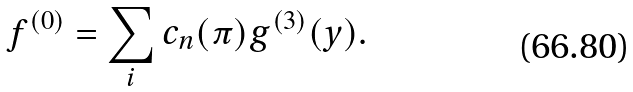Convert formula to latex. <formula><loc_0><loc_0><loc_500><loc_500>f ^ { ( 0 ) } = \sum _ { i } c _ { n } ( \pi ) g ^ { ( 3 ) } ( y ) .</formula> 